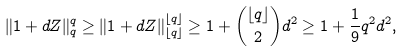Convert formula to latex. <formula><loc_0><loc_0><loc_500><loc_500>\| 1 + d Z \| _ { q } ^ { q } \geq \| 1 + d Z \| _ { \lfloor q \rfloor } ^ { \lfloor q \rfloor } \geq 1 + \binom { \lfloor q \rfloor } { 2 } d ^ { 2 } \geq 1 + \frac { 1 } { 9 } q ^ { 2 } d ^ { 2 } ,</formula> 